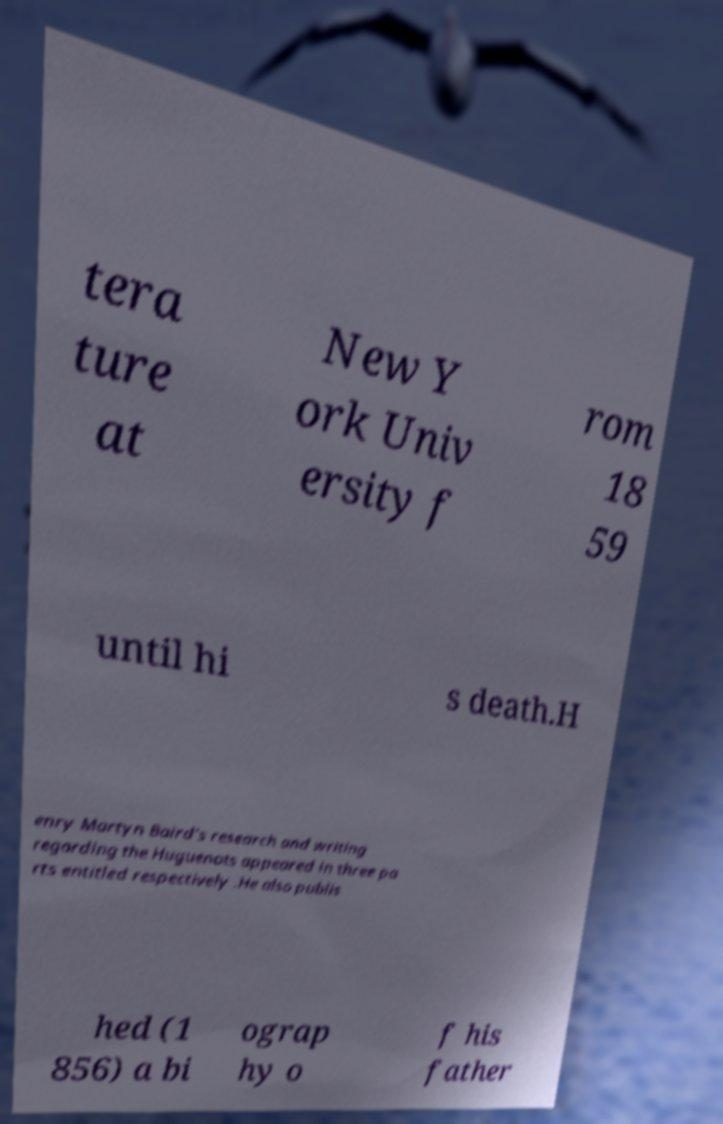Could you assist in decoding the text presented in this image and type it out clearly? tera ture at New Y ork Univ ersity f rom 18 59 until hi s death.H enry Martyn Baird's research and writing regarding the Huguenots appeared in three pa rts entitled respectively .He also publis hed (1 856) a bi ograp hy o f his father 